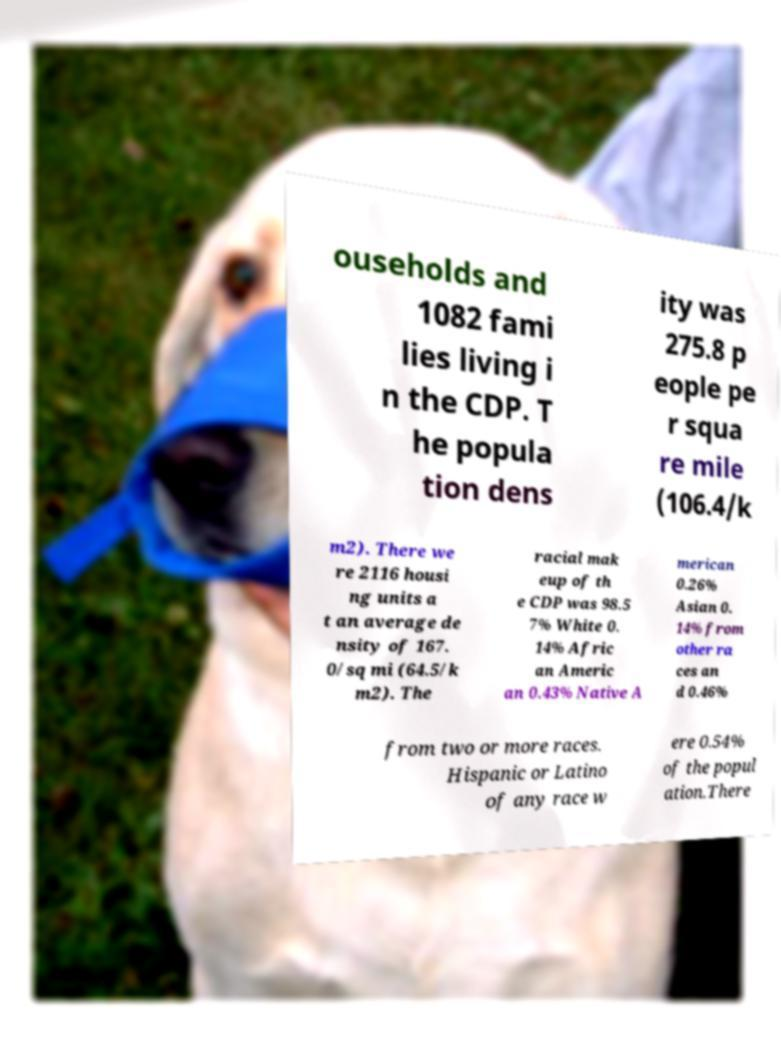Please read and relay the text visible in this image. What does it say? ouseholds and 1082 fami lies living i n the CDP. T he popula tion dens ity was 275.8 p eople pe r squa re mile (106.4/k m2). There we re 2116 housi ng units a t an average de nsity of 167. 0/sq mi (64.5/k m2). The racial mak eup of th e CDP was 98.5 7% White 0. 14% Afric an Americ an 0.43% Native A merican 0.26% Asian 0. 14% from other ra ces an d 0.46% from two or more races. Hispanic or Latino of any race w ere 0.54% of the popul ation.There 